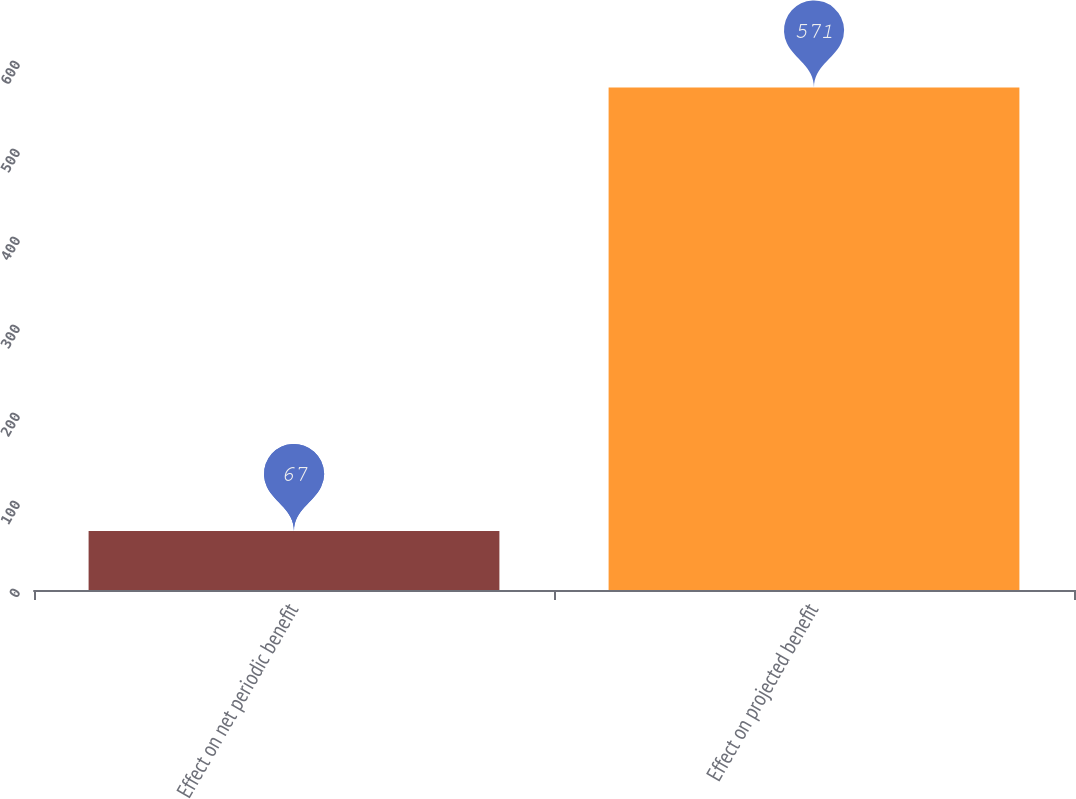<chart> <loc_0><loc_0><loc_500><loc_500><bar_chart><fcel>Effect on net periodic benefit<fcel>Effect on projected benefit<nl><fcel>67<fcel>571<nl></chart> 